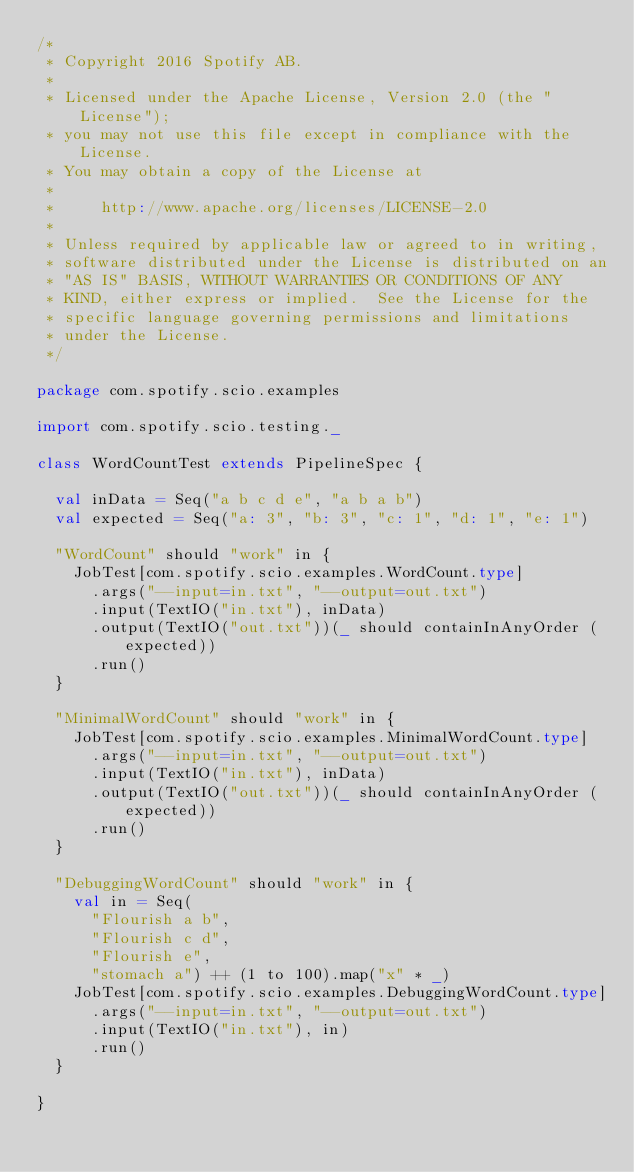Convert code to text. <code><loc_0><loc_0><loc_500><loc_500><_Scala_>/*
 * Copyright 2016 Spotify AB.
 *
 * Licensed under the Apache License, Version 2.0 (the "License");
 * you may not use this file except in compliance with the License.
 * You may obtain a copy of the License at
 *
 *     http://www.apache.org/licenses/LICENSE-2.0
 *
 * Unless required by applicable law or agreed to in writing,
 * software distributed under the License is distributed on an
 * "AS IS" BASIS, WITHOUT WARRANTIES OR CONDITIONS OF ANY
 * KIND, either express or implied.  See the License for the
 * specific language governing permissions and limitations
 * under the License.
 */

package com.spotify.scio.examples

import com.spotify.scio.testing._

class WordCountTest extends PipelineSpec {

  val inData = Seq("a b c d e", "a b a b")
  val expected = Seq("a: 3", "b: 3", "c: 1", "d: 1", "e: 1")

  "WordCount" should "work" in {
    JobTest[com.spotify.scio.examples.WordCount.type]
      .args("--input=in.txt", "--output=out.txt")
      .input(TextIO("in.txt"), inData)
      .output(TextIO("out.txt"))(_ should containInAnyOrder (expected))
      .run()
  }

  "MinimalWordCount" should "work" in {
    JobTest[com.spotify.scio.examples.MinimalWordCount.type]
      .args("--input=in.txt", "--output=out.txt")
      .input(TextIO("in.txt"), inData)
      .output(TextIO("out.txt"))(_ should containInAnyOrder (expected))
      .run()
  }

  "DebuggingWordCount" should "work" in {
    val in = Seq(
      "Flourish a b",
      "Flourish c d",
      "Flourish e",
      "stomach a") ++ (1 to 100).map("x" * _)
    JobTest[com.spotify.scio.examples.DebuggingWordCount.type]
      .args("--input=in.txt", "--output=out.txt")
      .input(TextIO("in.txt"), in)
      .run()
  }

}
</code> 